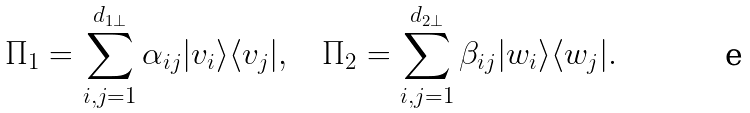Convert formula to latex. <formula><loc_0><loc_0><loc_500><loc_500>\Pi _ { 1 } = \sum _ { i , j = 1 } ^ { d _ { 1 \perp } } \alpha _ { i j } | v _ { i } \rangle \langle v _ { j } | , \quad \Pi _ { 2 } = \sum _ { i , j = 1 } ^ { d _ { 2 \perp } } \beta _ { i j } | w _ { i } \rangle \langle w _ { j } | .</formula> 